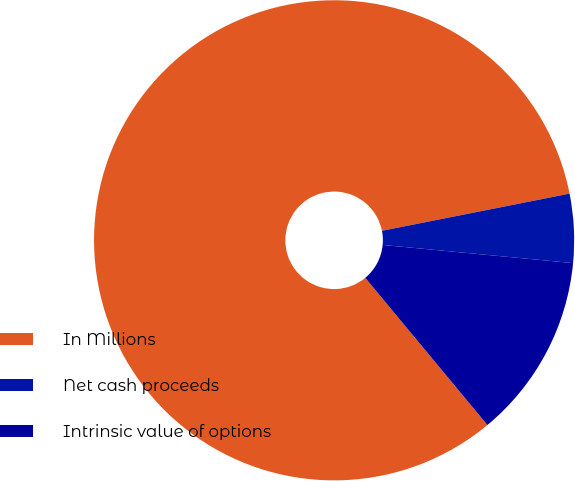Convert chart to OTSL. <chart><loc_0><loc_0><loc_500><loc_500><pie_chart><fcel>In Millions<fcel>Net cash proceeds<fcel>Intrinsic value of options<nl><fcel>82.91%<fcel>4.63%<fcel>12.46%<nl></chart> 